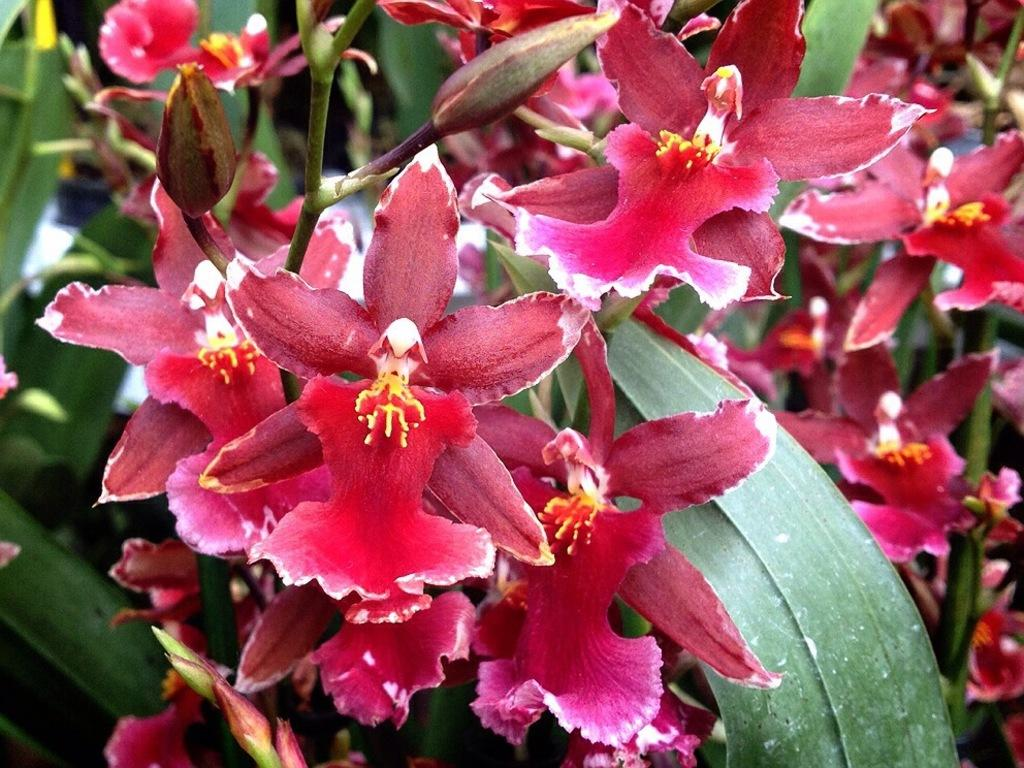What color are the flowers on the plant in the image? The flowers on the plant are pink in color. What stage of growth are some parts of the plant in? There are buds on the plant, which indicates that they are in the early stages of growth. What position does the plant hold in the competition? There is no competition present in the image, so it is not possible to determine the plant's position in any such event. How much wealth does the plant contribute to the owner's financial status? The image does not provide any information about the owner's financial status or the plant's contribution to it, as plants do not generate wealth. 